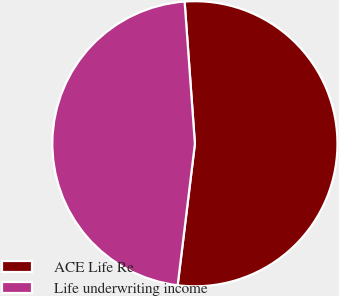Convert chart. <chart><loc_0><loc_0><loc_500><loc_500><pie_chart><fcel>ACE Life Re<fcel>Life underwriting income<nl><fcel>53.08%<fcel>46.92%<nl></chart> 